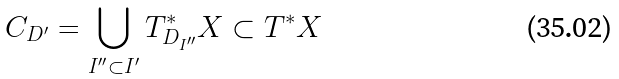Convert formula to latex. <formula><loc_0><loc_0><loc_500><loc_500>C _ { D ^ { \prime } } = \bigcup _ { I ^ { \prime \prime } \subset I ^ { \prime } } T ^ { * } _ { D _ { I ^ { \prime \prime } } } X \subset T ^ { * } X</formula> 